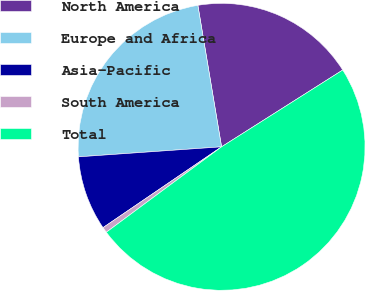Convert chart. <chart><loc_0><loc_0><loc_500><loc_500><pie_chart><fcel>North America<fcel>Europe and Africa<fcel>Asia-Pacific<fcel>South America<fcel>Total<nl><fcel>18.65%<fcel>23.47%<fcel>8.41%<fcel>0.63%<fcel>48.84%<nl></chart> 